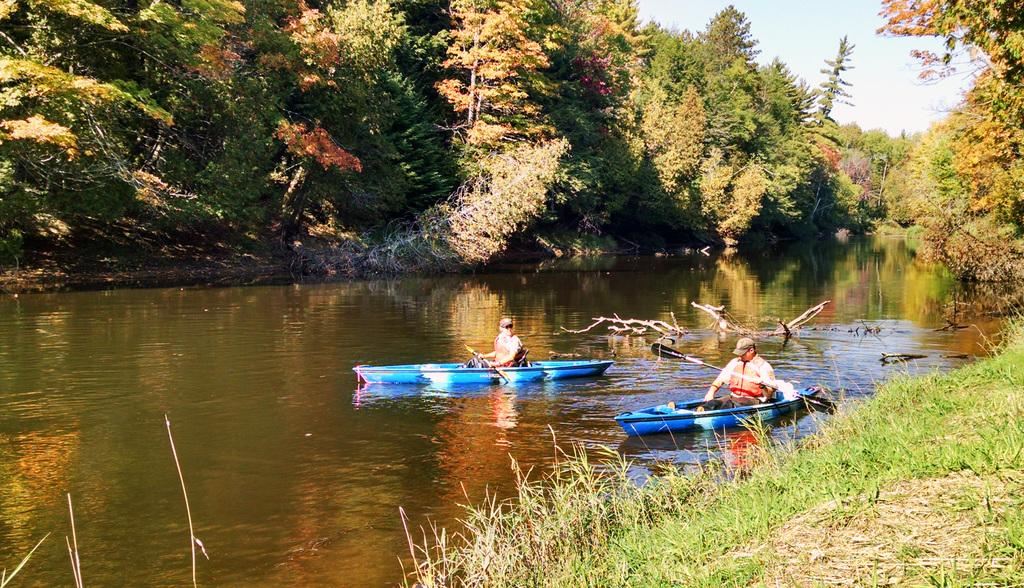How many people are in the image? There are two people in the image. What are the people doing in the image? The people are sailing boats. What are the people holding while sailing? The people are holding rows. What type of terrain is visible in the image? There is grass visible in the image. What body of water is present in the image? There is water visible in the image. What type of vegetation is present in the image? There is a group of trees in the image. What is the condition of the sky in the image? The sky is visible in the image and appears cloudy. What type of neck accessory is the governor wearing in the image? There is no governor or neck accessory present in the image. What thrilling activity are the people participating in while sailing? The image does not indicate any specific thrilling activity; the people are simply sailing boats. 